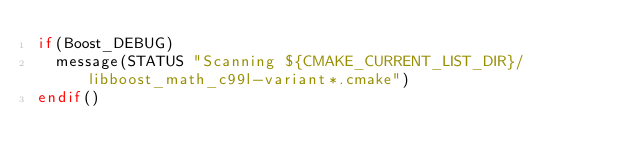Convert code to text. <code><loc_0><loc_0><loc_500><loc_500><_CMake_>if(Boost_DEBUG)
  message(STATUS "Scanning ${CMAKE_CURRENT_LIST_DIR}/libboost_math_c99l-variant*.cmake")
endif()
</code> 